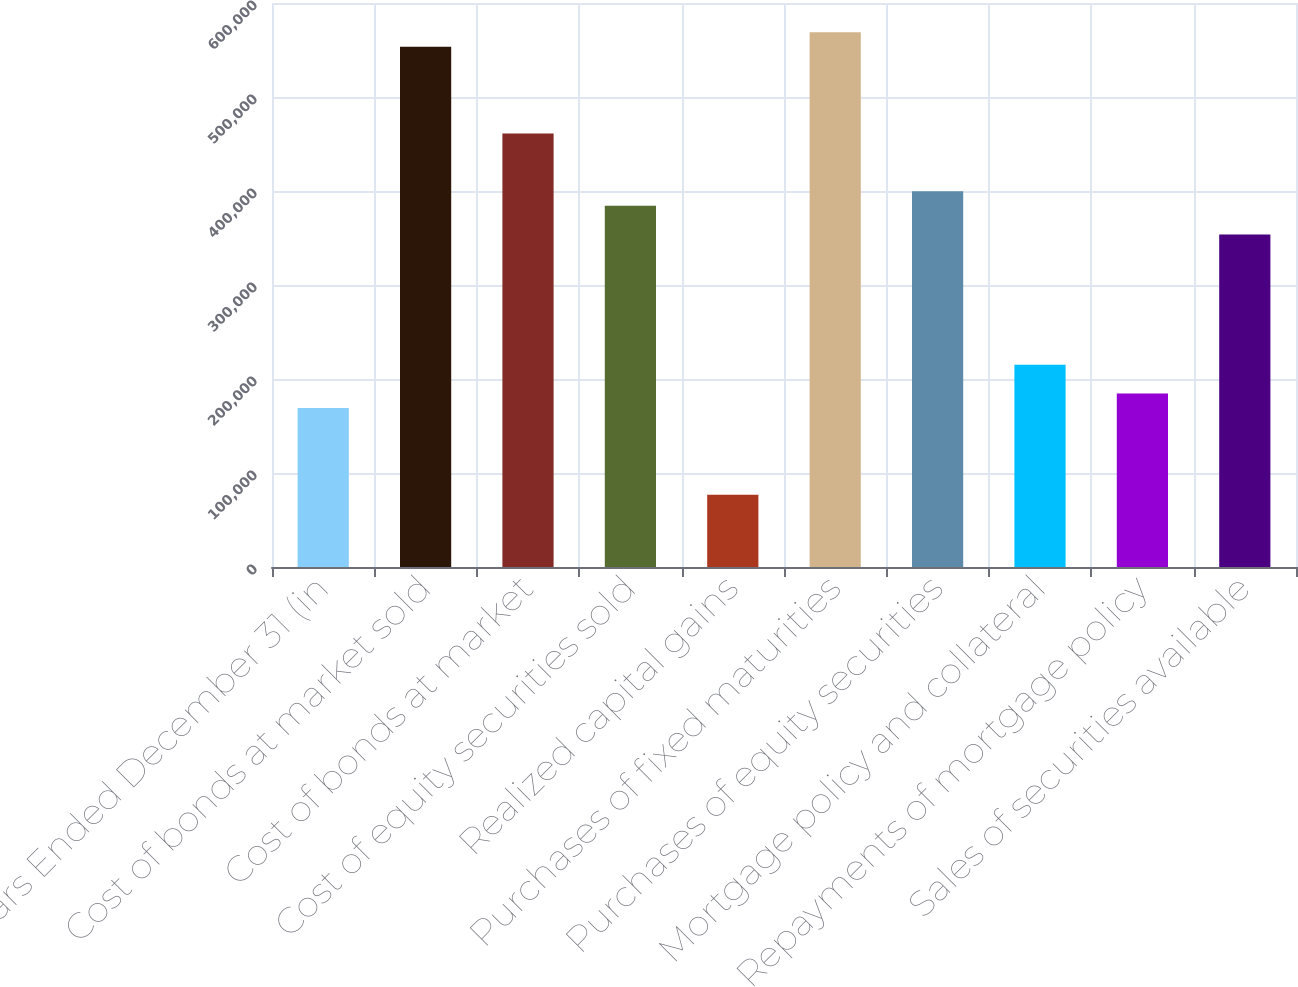Convert chart to OTSL. <chart><loc_0><loc_0><loc_500><loc_500><bar_chart><fcel>Years Ended December 31 (in<fcel>Cost of bonds at market sold<fcel>Cost of bonds at market<fcel>Cost of equity securities sold<fcel>Realized capital gains<fcel>Purchases of fixed maturities<fcel>Purchases of equity securities<fcel>Mortgage policy and collateral<fcel>Repayments of mortgage policy<fcel>Sales of securities available<nl><fcel>169116<fcel>553469<fcel>461224<fcel>384354<fcel>76871.5<fcel>568843<fcel>399728<fcel>215238<fcel>184490<fcel>353605<nl></chart> 